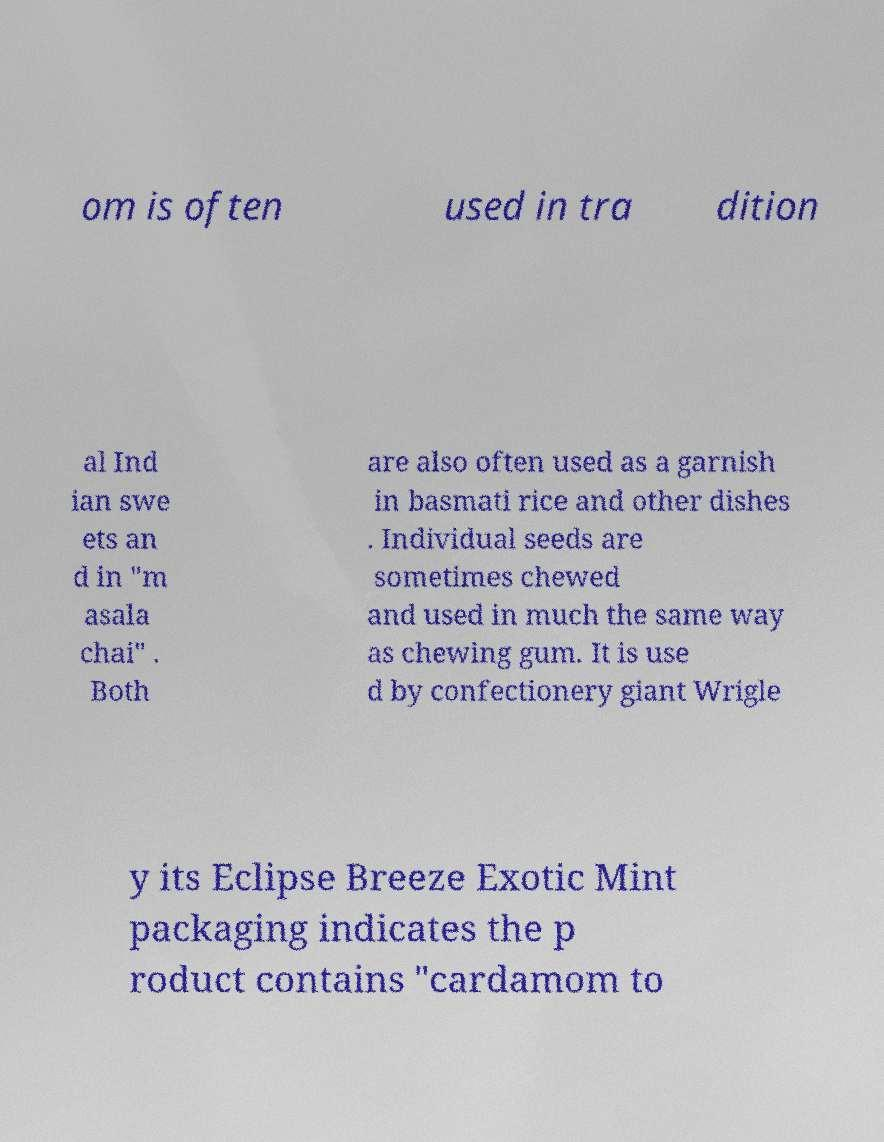Please identify and transcribe the text found in this image. om is often used in tra dition al Ind ian swe ets an d in "m asala chai" . Both are also often used as a garnish in basmati rice and other dishes . Individual seeds are sometimes chewed and used in much the same way as chewing gum. It is use d by confectionery giant Wrigle y its Eclipse Breeze Exotic Mint packaging indicates the p roduct contains "cardamom to 